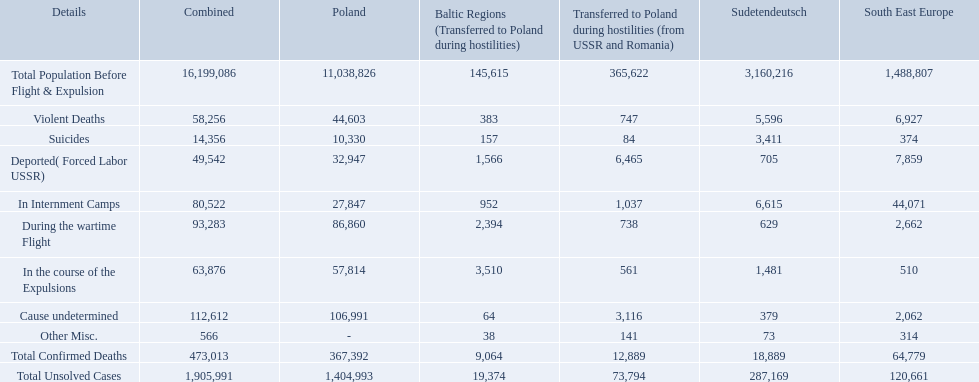What were the total number of confirmed deaths? 473,013. Of these, how many were violent? 58,256. What were all of the types of deaths? Violent Deaths, Suicides, Deported( Forced Labor USSR), In Internment Camps, During the wartime Flight, In the course of the Expulsions, Cause undetermined, Other Misc. And their totals in the baltic states? 383, 157, 1,566, 952, 2,394, 3,510, 64, 38. Were more deaths in the baltic states caused by undetermined causes or misc.? Cause undetermined. 